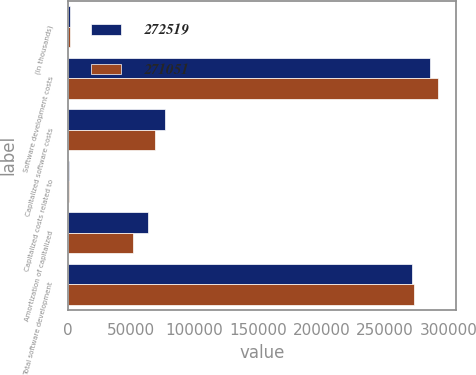Convert chart. <chart><loc_0><loc_0><loc_500><loc_500><stacked_bar_chart><ecel><fcel>(In thousands)<fcel>Software development costs<fcel>Capitalized software costs<fcel>Capitalized costs related to<fcel>Amortization of capitalized<fcel>Total software development<nl><fcel>272519<fcel>2009<fcel>285187<fcel>76876<fcel>871<fcel>63611<fcel>271051<nl><fcel>271051<fcel>2008<fcel>291368<fcel>69039<fcel>942<fcel>51132<fcel>272519<nl></chart> 